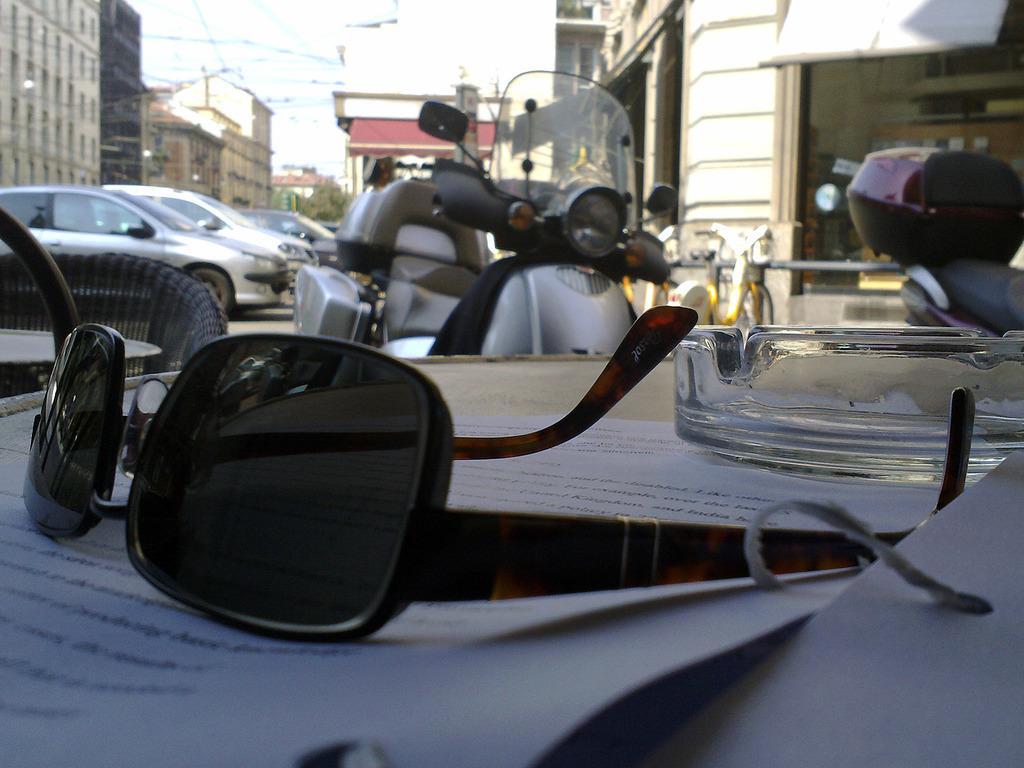Can you describe this image briefly? In this image I can see a table and on the table I can see few papers, a glass object and goggles. I can see few chairs, few vehicles, few trees, few buildings and the sky in the background. 